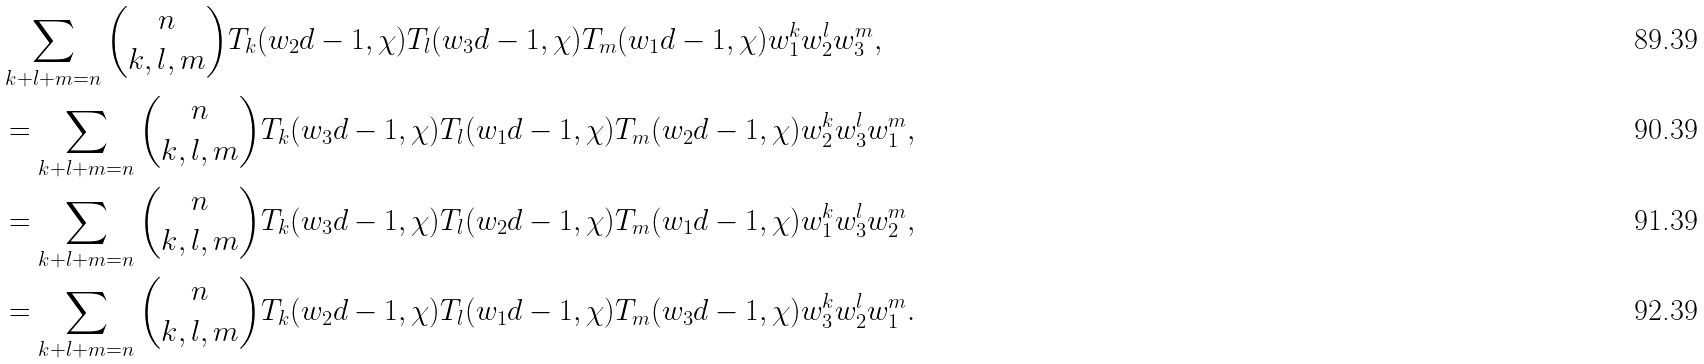<formula> <loc_0><loc_0><loc_500><loc_500>& \sum _ { k + l + m = n } \binom { n } { k , l , m } T _ { k } ( w _ { 2 } d - 1 , \chi ) T _ { l } ( w _ { 3 } d - 1 , \chi ) T _ { m } ( w _ { 1 } d - 1 , \chi ) w _ { 1 } ^ { k } w _ { 2 } ^ { l } w _ { 3 } ^ { m } , \\ & = \sum _ { k + l + m = n } \binom { n } { k , l , m } T _ { k } ( w _ { 3 } d - 1 , \chi ) T _ { l } ( w _ { 1 } d - 1 , \chi ) T _ { m } ( w _ { 2 } d - 1 , \chi ) w _ { 2 } ^ { k } w _ { 3 } ^ { l } w _ { 1 } ^ { m } , \\ & = \sum _ { k + l + m = n } \binom { n } { k , l , m } T _ { k } ( w _ { 3 } d - 1 , \chi ) T _ { l } ( w _ { 2 } d - 1 , \chi ) T _ { m } ( w _ { 1 } d - 1 , \chi ) w _ { 1 } ^ { k } w _ { 3 } ^ { l } w _ { 2 } ^ { m } , \\ & = \sum _ { k + l + m = n } \binom { n } { k , l , m } T _ { k } ( w _ { 2 } d - 1 , \chi ) T _ { l } ( w _ { 1 } d - 1 , \chi ) T _ { m } ( w _ { 3 } d - 1 , \chi ) w _ { 3 } ^ { k } w _ { 2 } ^ { l } w _ { 1 } ^ { m } .</formula> 